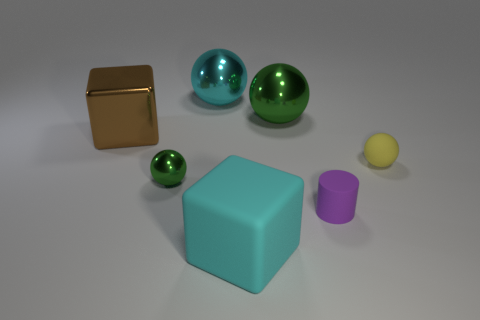Subtract 1 spheres. How many spheres are left? 3 Add 1 brown cubes. How many objects exist? 8 Subtract all cylinders. How many objects are left? 6 Subtract 0 yellow cylinders. How many objects are left? 7 Subtract all purple rubber cylinders. Subtract all tiny matte things. How many objects are left? 4 Add 5 purple rubber objects. How many purple rubber objects are left? 6 Add 5 large cyan shiny things. How many large cyan shiny things exist? 6 